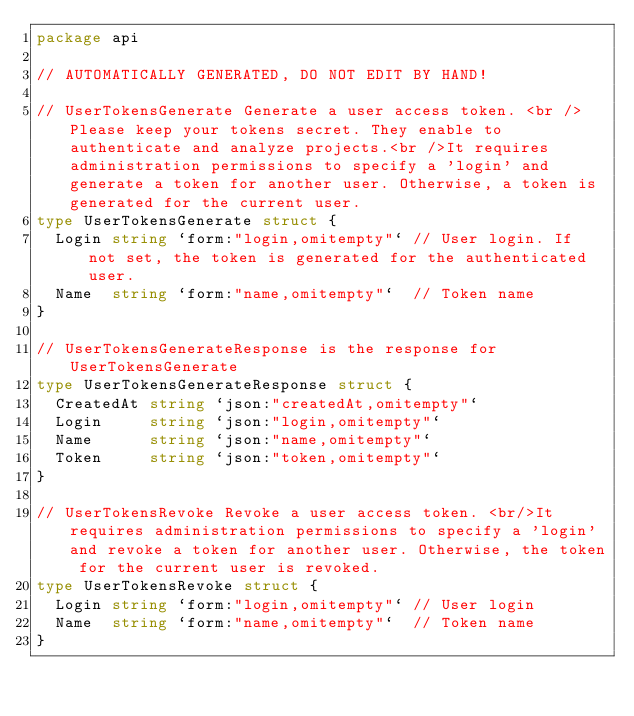<code> <loc_0><loc_0><loc_500><loc_500><_Go_>package api

// AUTOMATICALLY GENERATED, DO NOT EDIT BY HAND!

// UserTokensGenerate Generate a user access token. <br />Please keep your tokens secret. They enable to authenticate and analyze projects.<br />It requires administration permissions to specify a 'login' and generate a token for another user. Otherwise, a token is generated for the current user.
type UserTokensGenerate struct {
	Login string `form:"login,omitempty"` // User login. If not set, the token is generated for the authenticated user.
	Name  string `form:"name,omitempty"`  // Token name
}

// UserTokensGenerateResponse is the response for UserTokensGenerate
type UserTokensGenerateResponse struct {
	CreatedAt string `json:"createdAt,omitempty"`
	Login     string `json:"login,omitempty"`
	Name      string `json:"name,omitempty"`
	Token     string `json:"token,omitempty"`
}

// UserTokensRevoke Revoke a user access token. <br/>It requires administration permissions to specify a 'login' and revoke a token for another user. Otherwise, the token for the current user is revoked.
type UserTokensRevoke struct {
	Login string `form:"login,omitempty"` // User login
	Name  string `form:"name,omitempty"`  // Token name
}
</code> 